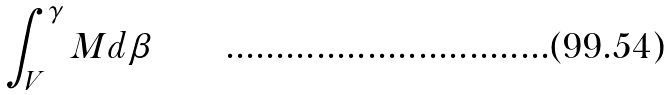Convert formula to latex. <formula><loc_0><loc_0><loc_500><loc_500>\int _ { V } ^ { \gamma } M d \beta</formula> 